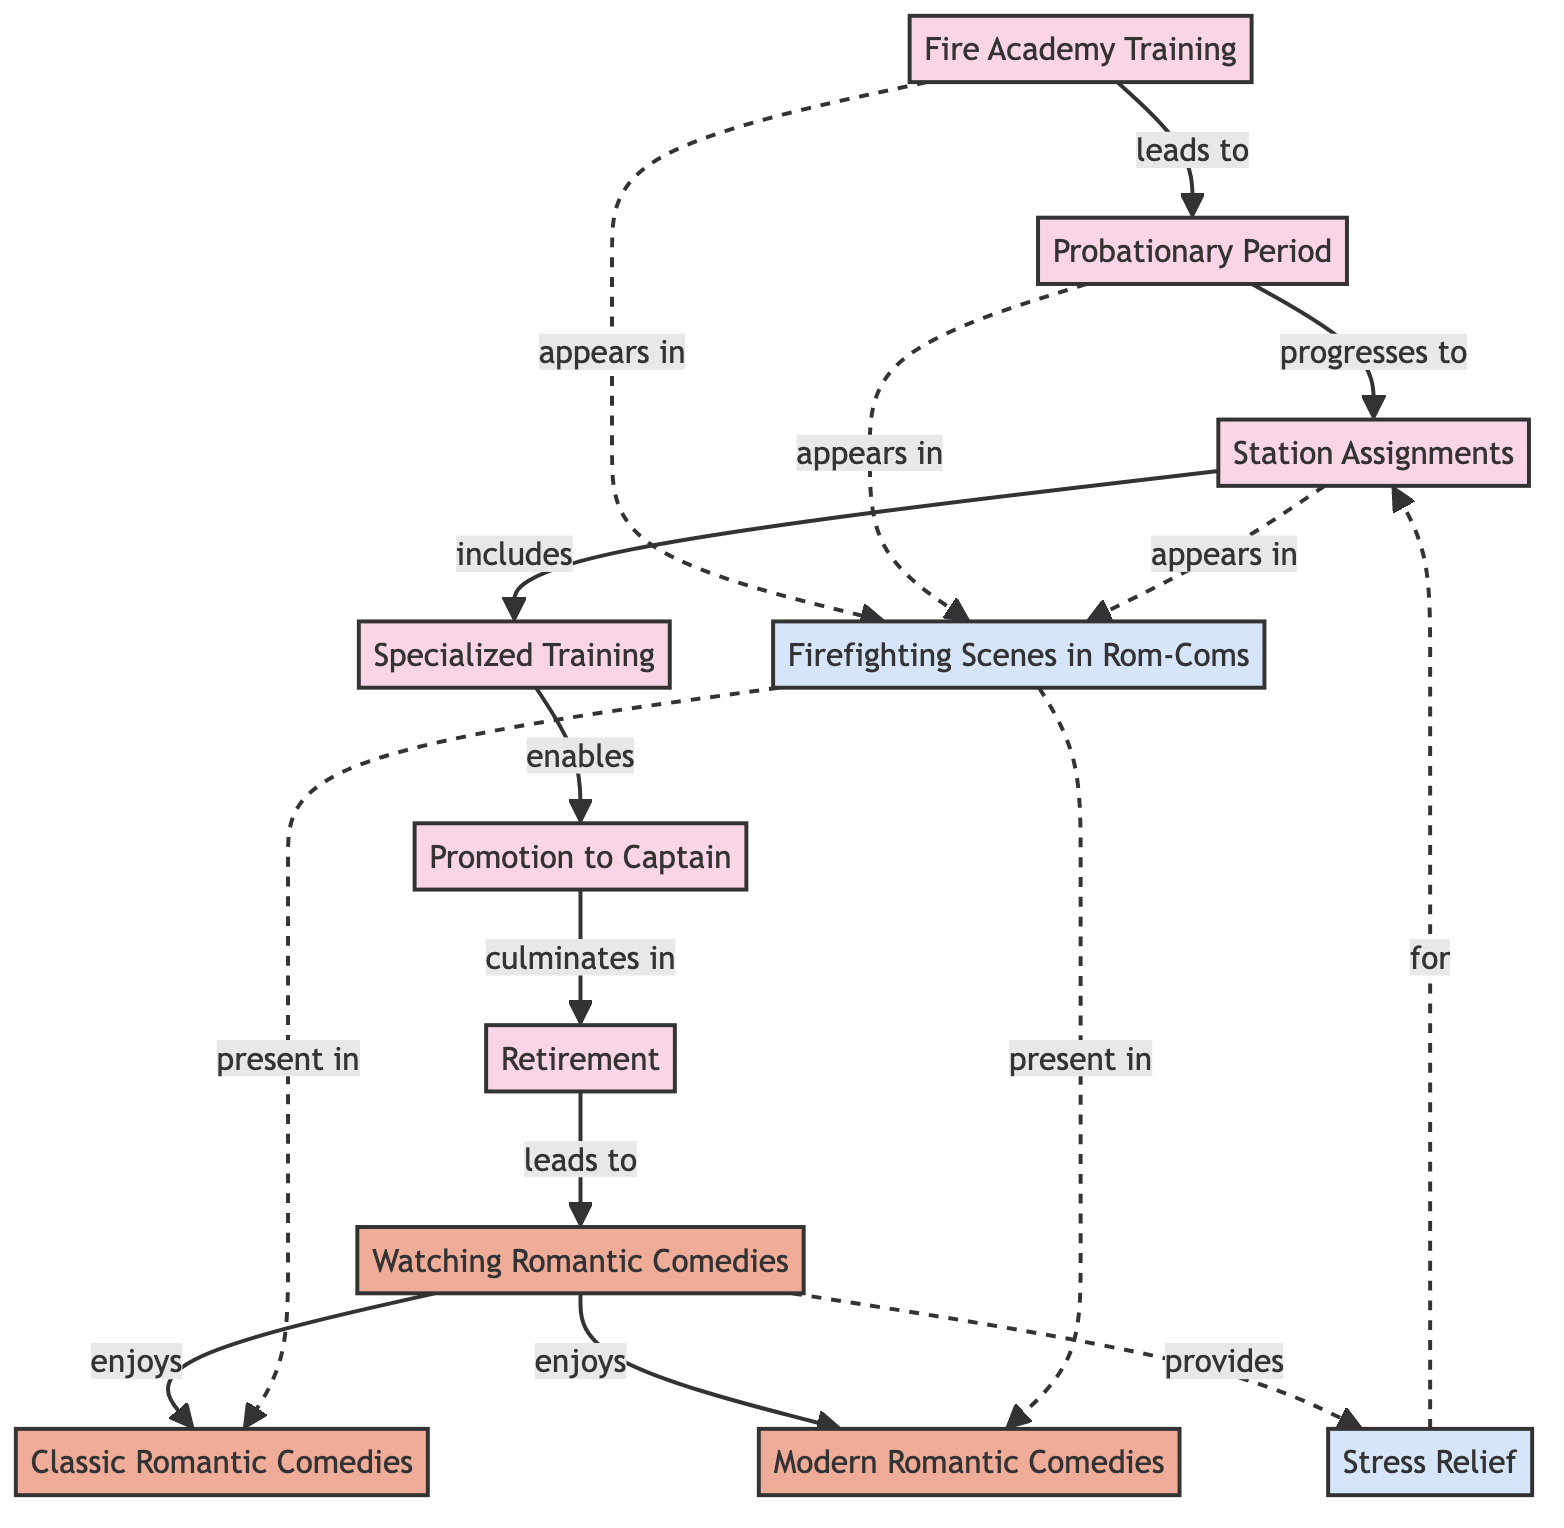What is the label of the node that represents the first year of active duty? The node describing the first year of active duty is labeled "Probationary Period". This can be found by identifying the node in the diagram that has a description indicating the first year under supervision.
Answer: Probationary Period How many nodes are categorized as "Career"? To find the number of nodes categorized as "Career", we count all the nodes and identify those that fall under this category. The nodes labeled "Fire Academy Training," "Probationary Period," "Station Assignments," "Specialized Training," "Promotion to Captain," and "Retirement" are all categorized under "Career". There are six of them.
Answer: 6 What is the relationship label between "Promotion to Captain" and "Retirement"? The relationship between "Promotion to Captain" and "Retirement" is labeled "culminates in". This relationship can be observed by tracing the edge connecting these two nodes in the diagram.
Answer: culminates in Which hobby is linked to providing stress relief? The hobby linked to providing stress relief is "Watching Romantic Comedies". The diagram shows an edge leading from the "Watching Romantic Comedies" node to the "Stress Relief" node, indicating this connection.
Answer: Watching Romantic Comedies What connections are labeled "appears in"? The connections labeled "appears in" connect the "Fire Academy Training," "Probationary Period," and "Station Assignments" nodes to the "Firefighting Scenes in Rom-Coms" node. This is indicated by the labels above the edges in the diagram that lead to the "Firefighting Scenes in Rom-Coms" node.
Answer: Fire Academy Training, Probationary Period, Station Assignments How do "Classic Romantic Comedies" and "Modern Romantic Comedies" relate to "Firefighting Scenes in Rom-Coms"? "Classic Romantic Comedies" and "Modern Romantic Comedies" are both connected to "Firefighting Scenes in Rom-Coms" through the relationship labeled "present in". This means that scenes featuring firefighting are present in both categories of romantic comedies. The edges leading from "Firefighting Scenes in Rom-Coms" confirm this connection.
Answer: present in Which node leads to "Retirement"? The node that leads to "Retirement" is "Promotion to Captain". This can be deduced by tracking the edge labeled "culminates in" from the "Promotion to Captain" node to the "Retirement" node.
Answer: Promotion to Captain What is the edge label connecting "Watching Romantic Comedies" and "Classic Romantic Comedies"? The edge connecting "Watching Romantic Comedies" and "Classic Romantic Comedies" is labeled "enjoys". This indicates a direct relationship where the activity of watching romantic comedies includes enjoyment of classic ones.
Answer: enjoys 